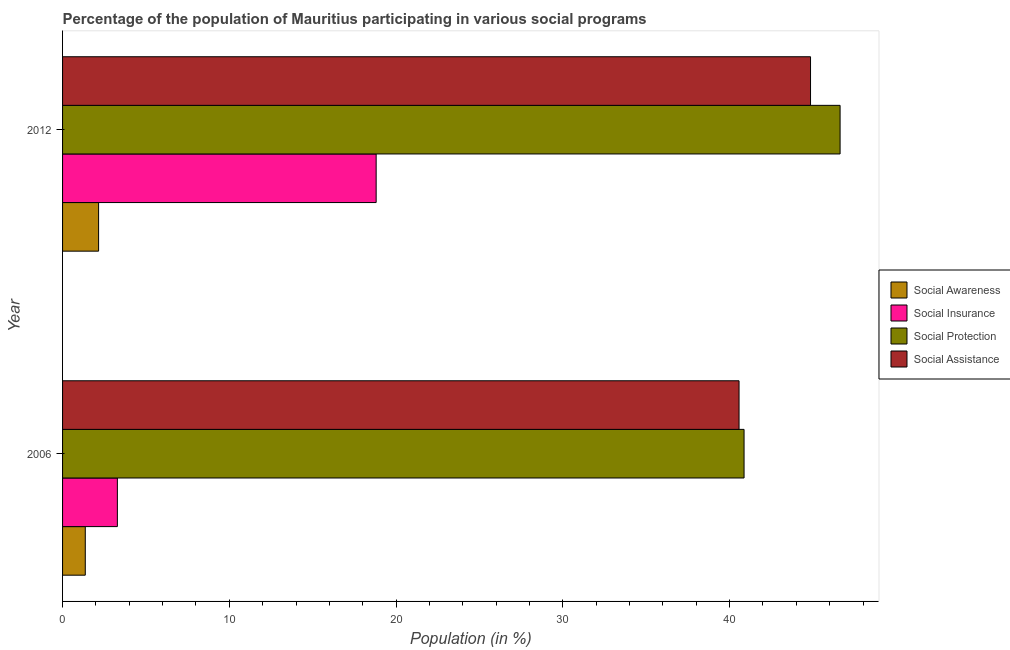Are the number of bars per tick equal to the number of legend labels?
Give a very brief answer. Yes. In how many cases, is the number of bars for a given year not equal to the number of legend labels?
Your response must be concise. 0. What is the participation of population in social assistance programs in 2012?
Give a very brief answer. 44.85. Across all years, what is the maximum participation of population in social insurance programs?
Give a very brief answer. 18.8. Across all years, what is the minimum participation of population in social awareness programs?
Offer a very short reply. 1.36. In which year was the participation of population in social insurance programs minimum?
Offer a very short reply. 2006. What is the total participation of population in social assistance programs in the graph?
Give a very brief answer. 85.42. What is the difference between the participation of population in social awareness programs in 2006 and that in 2012?
Offer a terse response. -0.8. What is the difference between the participation of population in social awareness programs in 2006 and the participation of population in social assistance programs in 2012?
Give a very brief answer. -43.49. What is the average participation of population in social assistance programs per year?
Offer a terse response. 42.71. In the year 2012, what is the difference between the participation of population in social assistance programs and participation of population in social protection programs?
Your answer should be compact. -1.77. In how many years, is the participation of population in social insurance programs greater than 46 %?
Your response must be concise. 0. What is the ratio of the participation of population in social awareness programs in 2006 to that in 2012?
Ensure brevity in your answer.  0.63. In how many years, is the participation of population in social protection programs greater than the average participation of population in social protection programs taken over all years?
Give a very brief answer. 1. What does the 3rd bar from the top in 2012 represents?
Give a very brief answer. Social Insurance. What does the 3rd bar from the bottom in 2006 represents?
Make the answer very short. Social Protection. Does the graph contain grids?
Make the answer very short. No. How are the legend labels stacked?
Keep it short and to the point. Vertical. What is the title of the graph?
Give a very brief answer. Percentage of the population of Mauritius participating in various social programs . What is the label or title of the Y-axis?
Your answer should be compact. Year. What is the Population (in %) of Social Awareness in 2006?
Ensure brevity in your answer.  1.36. What is the Population (in %) in Social Insurance in 2006?
Ensure brevity in your answer.  3.29. What is the Population (in %) of Social Protection in 2006?
Provide a succinct answer. 40.87. What is the Population (in %) of Social Assistance in 2006?
Your answer should be compact. 40.57. What is the Population (in %) in Social Awareness in 2012?
Provide a short and direct response. 2.16. What is the Population (in %) of Social Insurance in 2012?
Make the answer very short. 18.8. What is the Population (in %) in Social Protection in 2012?
Give a very brief answer. 46.63. What is the Population (in %) in Social Assistance in 2012?
Your answer should be very brief. 44.85. Across all years, what is the maximum Population (in %) of Social Awareness?
Your response must be concise. 2.16. Across all years, what is the maximum Population (in %) in Social Insurance?
Keep it short and to the point. 18.8. Across all years, what is the maximum Population (in %) of Social Protection?
Make the answer very short. 46.63. Across all years, what is the maximum Population (in %) of Social Assistance?
Your answer should be compact. 44.85. Across all years, what is the minimum Population (in %) of Social Awareness?
Offer a terse response. 1.36. Across all years, what is the minimum Population (in %) of Social Insurance?
Give a very brief answer. 3.29. Across all years, what is the minimum Population (in %) of Social Protection?
Give a very brief answer. 40.87. Across all years, what is the minimum Population (in %) in Social Assistance?
Provide a short and direct response. 40.57. What is the total Population (in %) of Social Awareness in the graph?
Make the answer very short. 3.52. What is the total Population (in %) of Social Insurance in the graph?
Provide a succinct answer. 22.09. What is the total Population (in %) in Social Protection in the graph?
Provide a succinct answer. 87.49. What is the total Population (in %) in Social Assistance in the graph?
Make the answer very short. 85.42. What is the difference between the Population (in %) of Social Awareness in 2006 and that in 2012?
Keep it short and to the point. -0.8. What is the difference between the Population (in %) of Social Insurance in 2006 and that in 2012?
Provide a succinct answer. -15.52. What is the difference between the Population (in %) of Social Protection in 2006 and that in 2012?
Provide a short and direct response. -5.76. What is the difference between the Population (in %) in Social Assistance in 2006 and that in 2012?
Provide a short and direct response. -4.29. What is the difference between the Population (in %) of Social Awareness in 2006 and the Population (in %) of Social Insurance in 2012?
Provide a succinct answer. -17.44. What is the difference between the Population (in %) of Social Awareness in 2006 and the Population (in %) of Social Protection in 2012?
Make the answer very short. -45.26. What is the difference between the Population (in %) of Social Awareness in 2006 and the Population (in %) of Social Assistance in 2012?
Offer a terse response. -43.49. What is the difference between the Population (in %) in Social Insurance in 2006 and the Population (in %) in Social Protection in 2012?
Give a very brief answer. -43.34. What is the difference between the Population (in %) of Social Insurance in 2006 and the Population (in %) of Social Assistance in 2012?
Offer a very short reply. -41.57. What is the difference between the Population (in %) in Social Protection in 2006 and the Population (in %) in Social Assistance in 2012?
Give a very brief answer. -3.99. What is the average Population (in %) of Social Awareness per year?
Your response must be concise. 1.76. What is the average Population (in %) in Social Insurance per year?
Ensure brevity in your answer.  11.05. What is the average Population (in %) in Social Protection per year?
Your answer should be very brief. 43.75. What is the average Population (in %) of Social Assistance per year?
Your answer should be compact. 42.71. In the year 2006, what is the difference between the Population (in %) of Social Awareness and Population (in %) of Social Insurance?
Keep it short and to the point. -1.92. In the year 2006, what is the difference between the Population (in %) of Social Awareness and Population (in %) of Social Protection?
Your answer should be very brief. -39.51. In the year 2006, what is the difference between the Population (in %) of Social Awareness and Population (in %) of Social Assistance?
Offer a terse response. -39.2. In the year 2006, what is the difference between the Population (in %) in Social Insurance and Population (in %) in Social Protection?
Your answer should be very brief. -37.58. In the year 2006, what is the difference between the Population (in %) of Social Insurance and Population (in %) of Social Assistance?
Your answer should be very brief. -37.28. In the year 2006, what is the difference between the Population (in %) in Social Protection and Population (in %) in Social Assistance?
Give a very brief answer. 0.3. In the year 2012, what is the difference between the Population (in %) of Social Awareness and Population (in %) of Social Insurance?
Provide a succinct answer. -16.64. In the year 2012, what is the difference between the Population (in %) of Social Awareness and Population (in %) of Social Protection?
Make the answer very short. -44.47. In the year 2012, what is the difference between the Population (in %) in Social Awareness and Population (in %) in Social Assistance?
Give a very brief answer. -42.69. In the year 2012, what is the difference between the Population (in %) in Social Insurance and Population (in %) in Social Protection?
Your answer should be compact. -27.82. In the year 2012, what is the difference between the Population (in %) in Social Insurance and Population (in %) in Social Assistance?
Give a very brief answer. -26.05. In the year 2012, what is the difference between the Population (in %) of Social Protection and Population (in %) of Social Assistance?
Your answer should be very brief. 1.77. What is the ratio of the Population (in %) of Social Awareness in 2006 to that in 2012?
Offer a very short reply. 0.63. What is the ratio of the Population (in %) of Social Insurance in 2006 to that in 2012?
Ensure brevity in your answer.  0.17. What is the ratio of the Population (in %) of Social Protection in 2006 to that in 2012?
Ensure brevity in your answer.  0.88. What is the ratio of the Population (in %) of Social Assistance in 2006 to that in 2012?
Your response must be concise. 0.9. What is the difference between the highest and the second highest Population (in %) of Social Awareness?
Your answer should be very brief. 0.8. What is the difference between the highest and the second highest Population (in %) of Social Insurance?
Ensure brevity in your answer.  15.52. What is the difference between the highest and the second highest Population (in %) in Social Protection?
Your response must be concise. 5.76. What is the difference between the highest and the second highest Population (in %) of Social Assistance?
Offer a terse response. 4.29. What is the difference between the highest and the lowest Population (in %) of Social Awareness?
Provide a short and direct response. 0.8. What is the difference between the highest and the lowest Population (in %) in Social Insurance?
Offer a terse response. 15.52. What is the difference between the highest and the lowest Population (in %) in Social Protection?
Your response must be concise. 5.76. What is the difference between the highest and the lowest Population (in %) of Social Assistance?
Give a very brief answer. 4.29. 